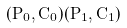<formula> <loc_0><loc_0><loc_500><loc_500>( P _ { 0 } , C _ { 0 } ) ( P _ { 1 } , C _ { 1 } )</formula> 